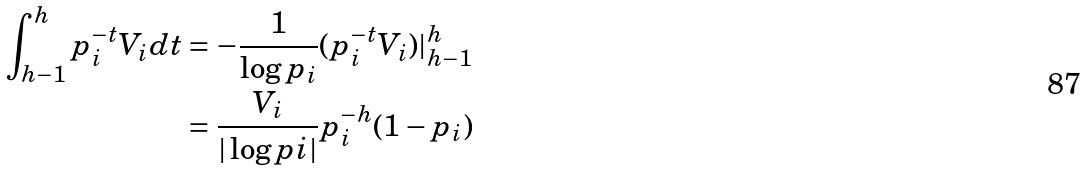<formula> <loc_0><loc_0><loc_500><loc_500>\int _ { h - 1 } ^ { h } p _ { i } ^ { - t } V _ { i } d t & = - \frac { 1 } { \log { p _ { i } } } ( p _ { i } ^ { - t } V _ { i } ) | _ { h - 1 } ^ { h } \\ & = \frac { V _ { i } } { | \log { p i } | } p _ { i } ^ { - h } ( 1 - p _ { i } )</formula> 